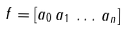Convert formula to latex. <formula><loc_0><loc_0><loc_500><loc_500>f = [ a _ { 0 } \, a _ { 1 } \, \dots \, a _ { n } ]</formula> 